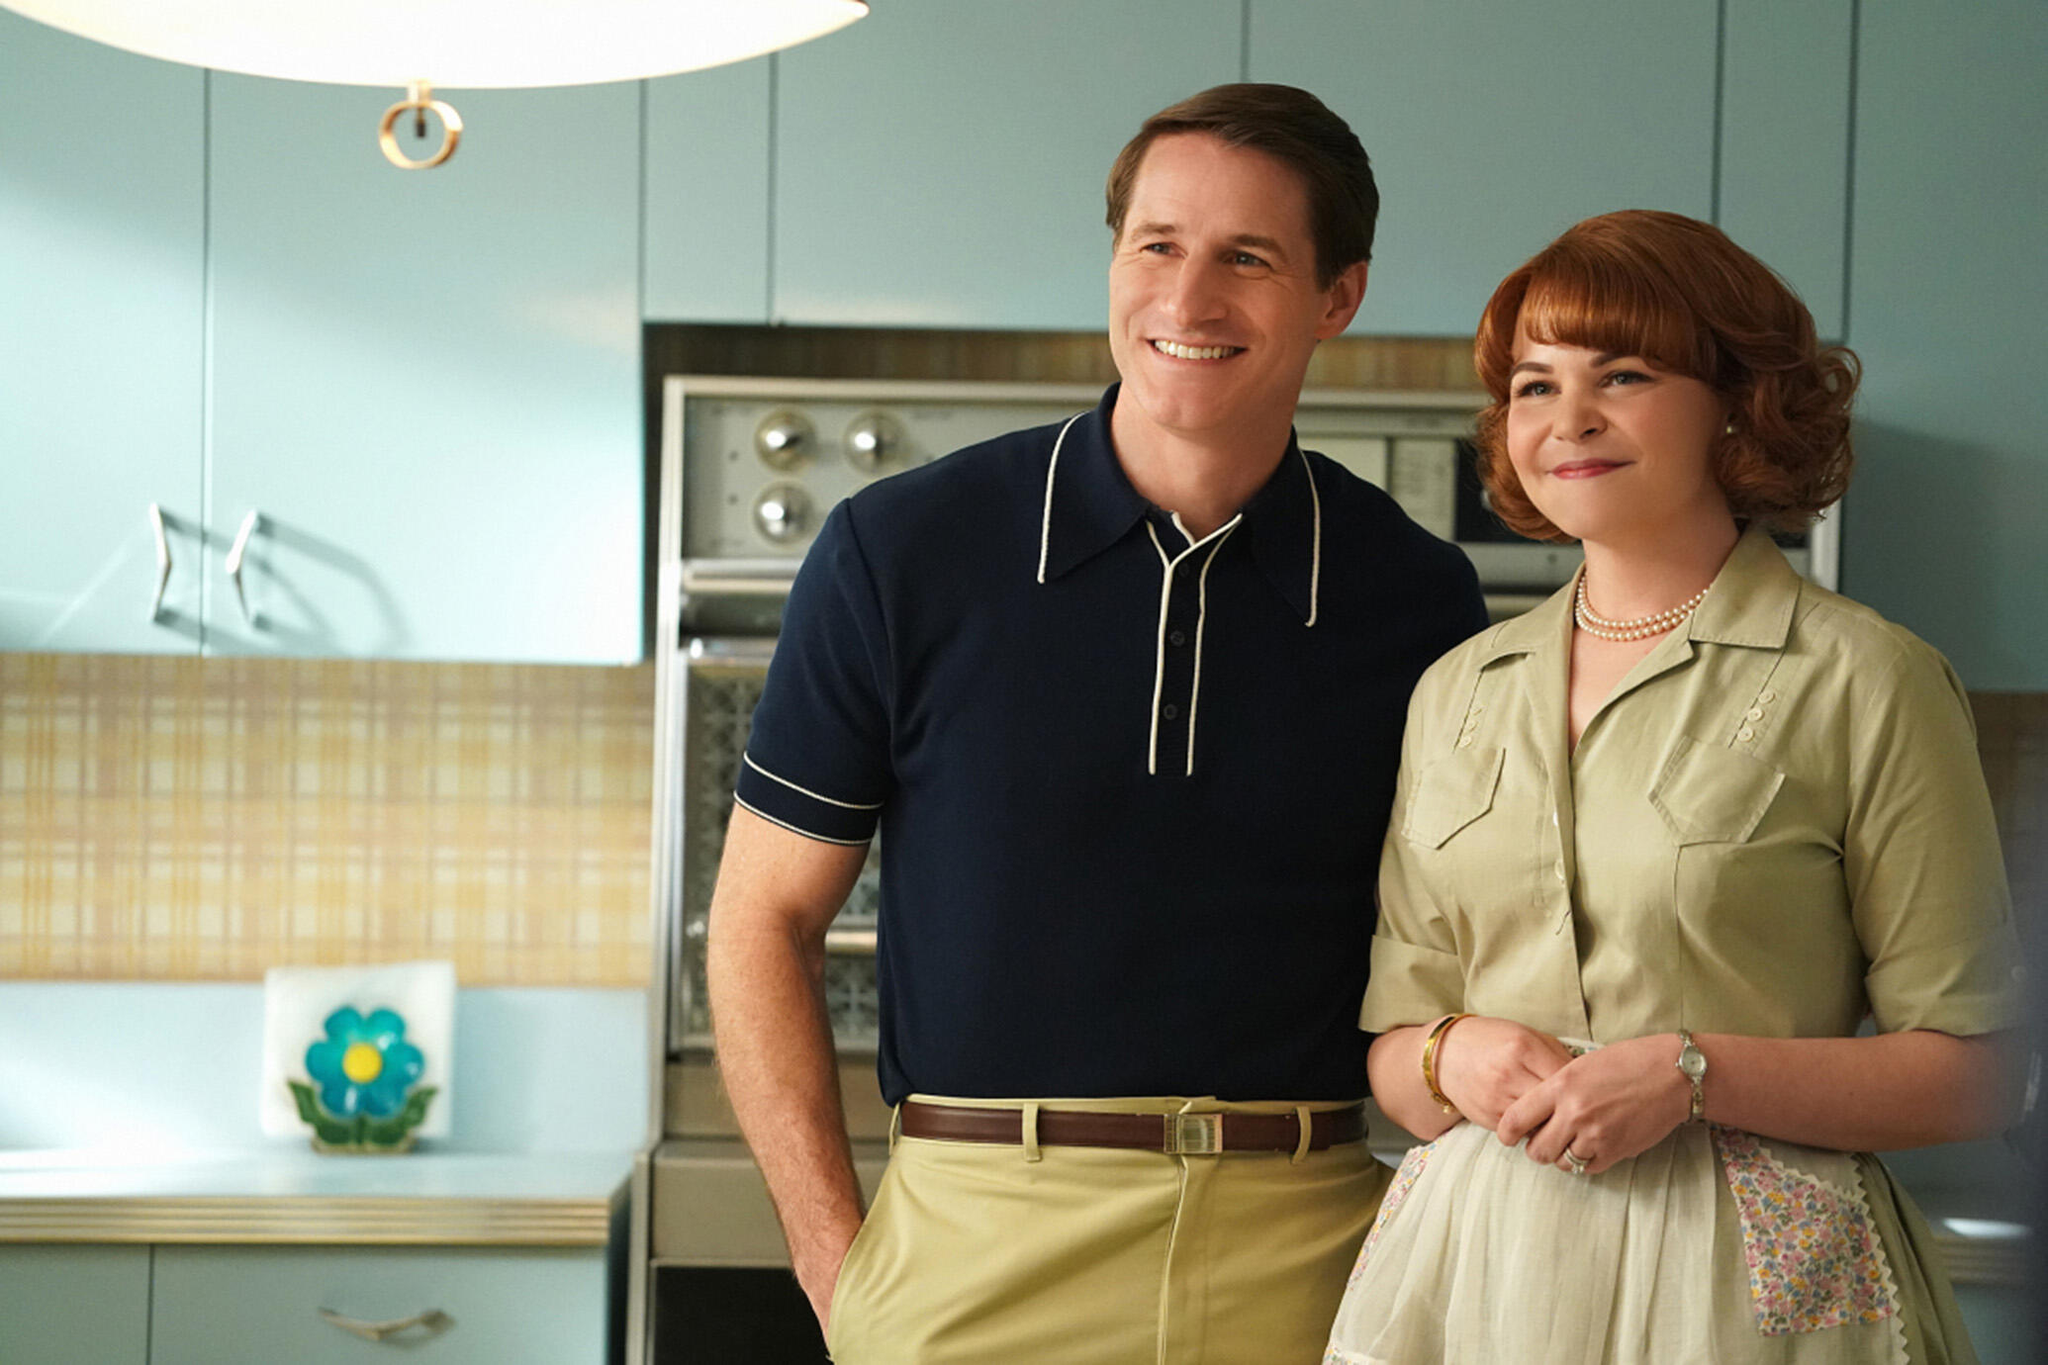What is this photo about? The image captures two actors in a vintage-style kitchen setting, designed to evoke a mid-20th century aesthetic. The man is dressed in a blue polo shirt with white trim and khaki pants, exuding a casual yet neat appearance. The woman alongside him wears a light green dress complemented with a subtle floral pattern apron, accessorized with a pearl necklace and a watch, enhancing her poised and elegant demeanor. The background features a pastel blue refrigerator and a tile countertop, adding to the retro ambiance. Their smiling expressions and close stance suggest a scene intended to portray a cheerful, domestic life. 